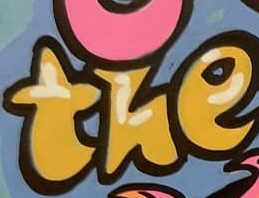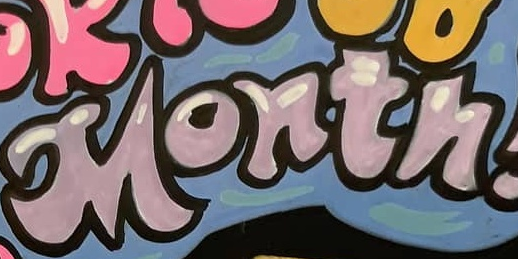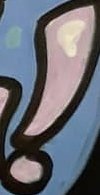Read the text content from these images in order, separated by a semicolon. the; Month; ! 